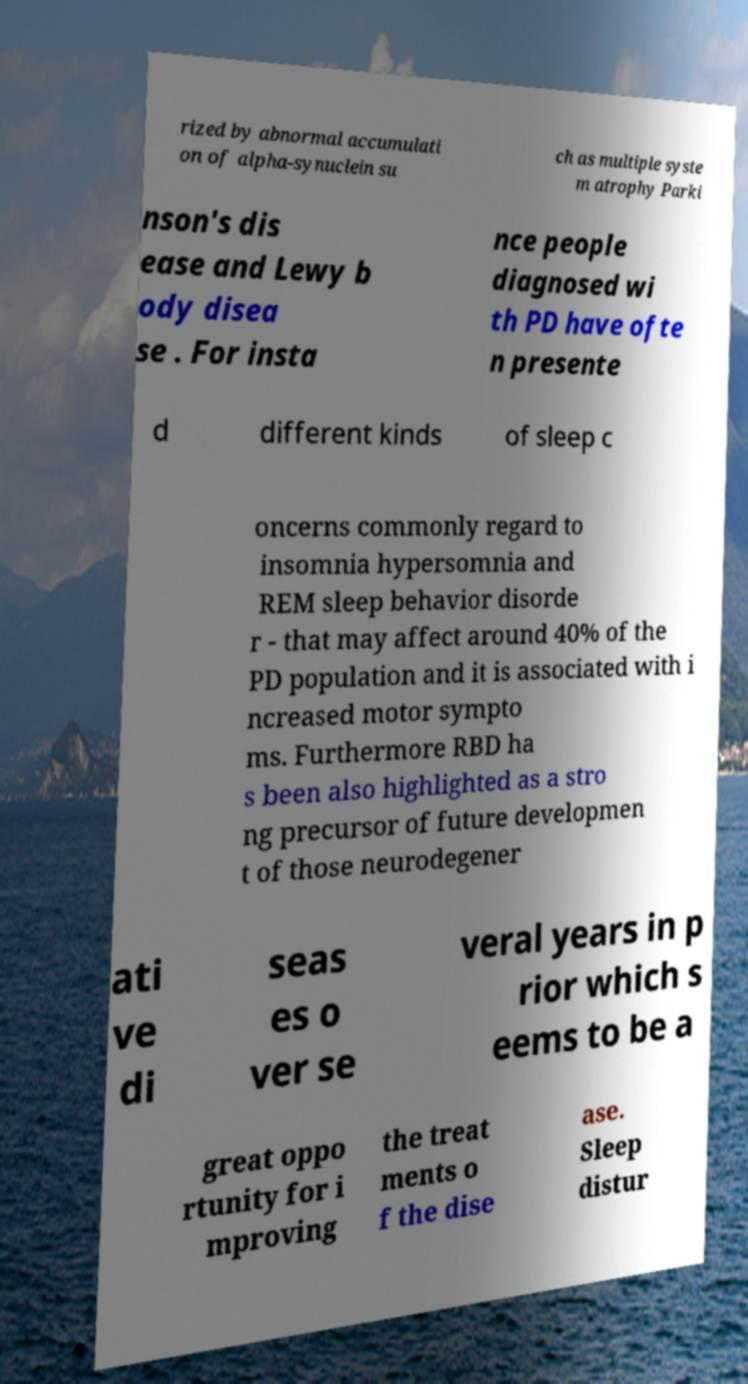Can you read and provide the text displayed in the image?This photo seems to have some interesting text. Can you extract and type it out for me? rized by abnormal accumulati on of alpha-synuclein su ch as multiple syste m atrophy Parki nson's dis ease and Lewy b ody disea se . For insta nce people diagnosed wi th PD have ofte n presente d different kinds of sleep c oncerns commonly regard to insomnia hypersomnia and REM sleep behavior disorde r - that may affect around 40% of the PD population and it is associated with i ncreased motor sympto ms. Furthermore RBD ha s been also highlighted as a stro ng precursor of future developmen t of those neurodegener ati ve di seas es o ver se veral years in p rior which s eems to be a great oppo rtunity for i mproving the treat ments o f the dise ase. Sleep distur 